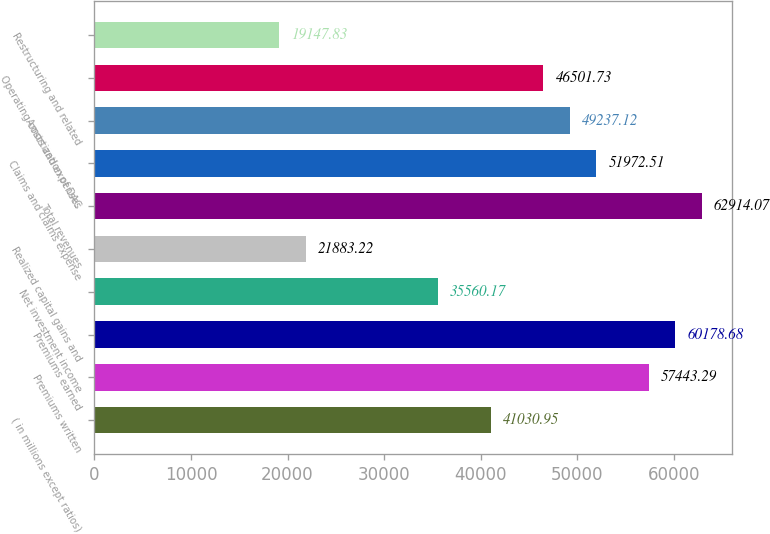Convert chart to OTSL. <chart><loc_0><loc_0><loc_500><loc_500><bar_chart><fcel>( in millions except ratios)<fcel>Premiums written<fcel>Premiums earned<fcel>Net investment income<fcel>Realized capital gains and<fcel>Total revenues<fcel>Claims and claims expense<fcel>Amortization of DAC<fcel>Operating costs and expenses<fcel>Restructuring and related<nl><fcel>41030.9<fcel>57443.3<fcel>60178.7<fcel>35560.2<fcel>21883.2<fcel>62914.1<fcel>51972.5<fcel>49237.1<fcel>46501.7<fcel>19147.8<nl></chart> 